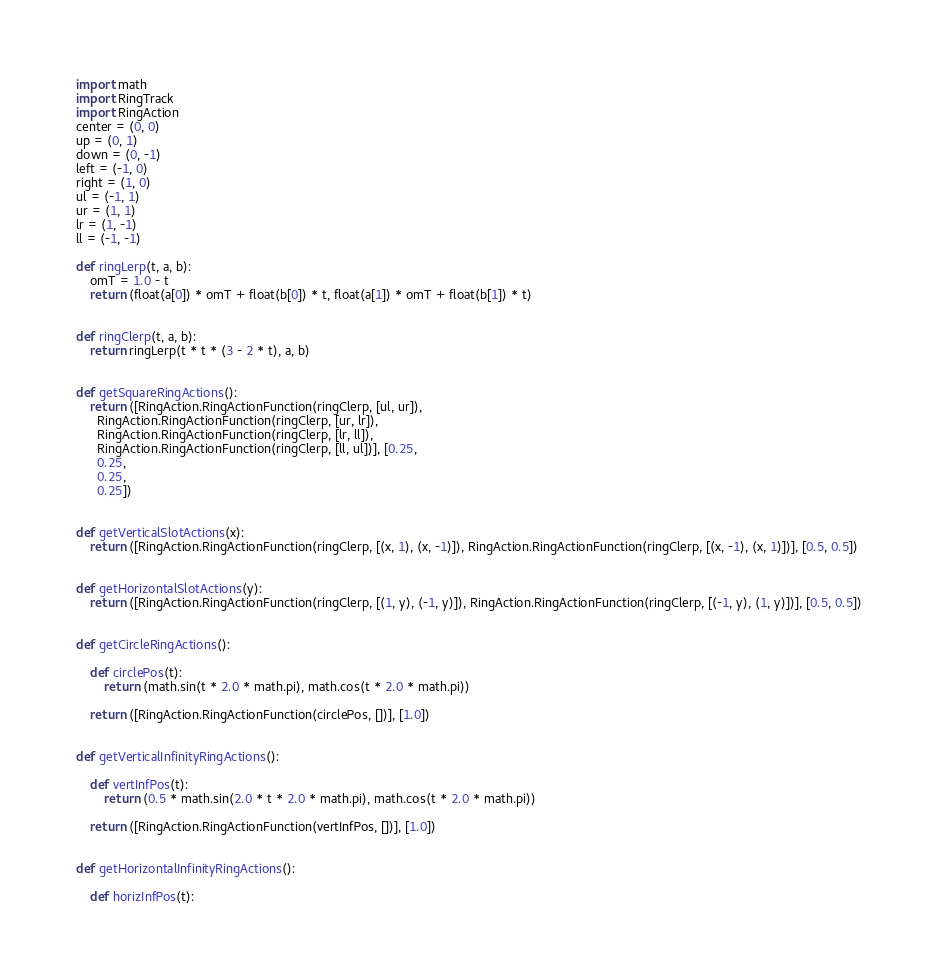<code> <loc_0><loc_0><loc_500><loc_500><_Python_>import math
import RingTrack
import RingAction
center = (0, 0)
up = (0, 1)
down = (0, -1)
left = (-1, 0)
right = (1, 0)
ul = (-1, 1)
ur = (1, 1)
lr = (1, -1)
ll = (-1, -1)

def ringLerp(t, a, b):
    omT = 1.0 - t
    return (float(a[0]) * omT + float(b[0]) * t, float(a[1]) * omT + float(b[1]) * t)


def ringClerp(t, a, b):
    return ringLerp(t * t * (3 - 2 * t), a, b)


def getSquareRingActions():
    return ([RingAction.RingActionFunction(ringClerp, [ul, ur]),
      RingAction.RingActionFunction(ringClerp, [ur, lr]),
      RingAction.RingActionFunction(ringClerp, [lr, ll]),
      RingAction.RingActionFunction(ringClerp, [ll, ul])], [0.25,
      0.25,
      0.25,
      0.25])


def getVerticalSlotActions(x):
    return ([RingAction.RingActionFunction(ringClerp, [(x, 1), (x, -1)]), RingAction.RingActionFunction(ringClerp, [(x, -1), (x, 1)])], [0.5, 0.5])


def getHorizontalSlotActions(y):
    return ([RingAction.RingActionFunction(ringClerp, [(1, y), (-1, y)]), RingAction.RingActionFunction(ringClerp, [(-1, y), (1, y)])], [0.5, 0.5])


def getCircleRingActions():

    def circlePos(t):
        return (math.sin(t * 2.0 * math.pi), math.cos(t * 2.0 * math.pi))

    return ([RingAction.RingActionFunction(circlePos, [])], [1.0])


def getVerticalInfinityRingActions():

    def vertInfPos(t):
        return (0.5 * math.sin(2.0 * t * 2.0 * math.pi), math.cos(t * 2.0 * math.pi))

    return ([RingAction.RingActionFunction(vertInfPos, [])], [1.0])


def getHorizontalInfinityRingActions():

    def horizInfPos(t):</code> 